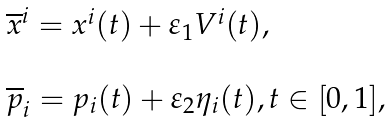<formula> <loc_0><loc_0><loc_500><loc_500>\begin{array} { l } \overline { x } ^ { i } = x ^ { i } ( t ) + \varepsilon _ { 1 } V ^ { i } ( t ) , \\ \\ \overline { p } _ { i } = p _ { i } ( t ) + \varepsilon _ { 2 } \eta _ { i } ( t ) , t \in [ 0 , 1 ] , \end{array}</formula> 